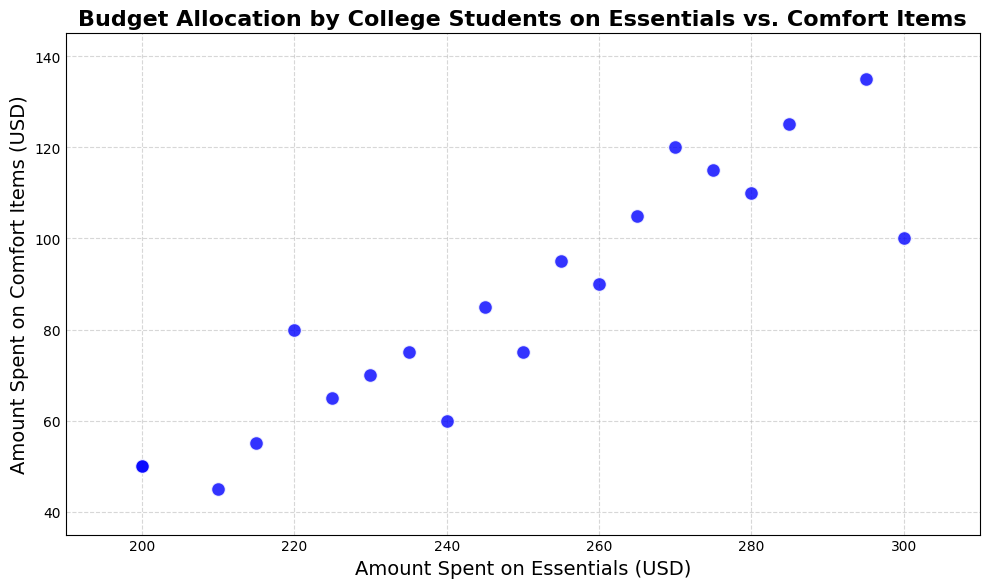What is the range of amounts spent on essentials? Identify the minimum and maximum values spent on essentials from the scatter plot, which are 200 and 300 respectively. The range is calculated as 300 - 200 = 100.
Answer: 100 Which student spent the most on comfort items? Observe the data points and identify which one has the highest value on the y-axis. Student 20 has the highest value of 135 for comfort items.
Answer: Student 20 Is there a positive correlation between the amount spent on essentials and comfort items? Look at the scatter plot to determine if as the amount spent on essentials increases, the amount spent on comfort items also increases. The trend seems to be positively correlated as the points create an upward slope trend.
Answer: Yes What is the average amount spent on comfort items? Sum all the values spent on comfort items and divide by the number of students: (50 + 75 + 100 + 80 + 90 + 60 + 110 + 70 + 120 + 50 + 45 + 55 + 65 + 75 + 85 + 95 + 105 + 115 + 125 + 135) / 20 = 94.5.
Answer: 94.5 Which student is the outlier with significantly lower or higher spending on comfort items compared to their spending on essentials? Compare all points and notice Student 20, who has high spending on both essentials and comfort items, making it somewhat an outlier.
Answer: Student 20 What is the median amount spent on essentials? Organize the spending amounts on essentials in ascending order and find the middle value(s). With 20 numbers: the median is the average of the 10th and 11th values which are both 240 and 245, so (240 + 245)/2 = 247.5.
Answer: 247.5 How many students spend above average on comfort items? First identify the average spent on comfort items as 94.5. Count the number of students spending above this value: Students 7 (110), 9 (120), 17 (105), 18 (115), 19 (125), and 20 (135) total 6.
Answer: 6 Compare the spending patterns of Student 1 and Student 10. Look at their positions on the plot: both Student 1 and Student 10 spent the same, $200 on essentials and $50 on comfort items. Thus, their spending patterns are identical.
Answer: Identical Are there any students who spent the same amount on essentials but different amounts on comfort items? Compare the x-values and look for duplicate values. Students 1 and 10 both spent $200 on essentials but the same amount on comfort items too, making this irrelevant, confirm others as distinct.
Answer: No What is the total amount spent on essentials by all students? Sum all the values spent on essentials across all students: 200 + 250 + 300 + 220 + 260 + 240 + 280 + 230 + 270 + 200 + 210 + 215 + 225 + 235 + 245 + 255 + 265 + 275 + 285 + 295 = 4725.
Answer: 4725 